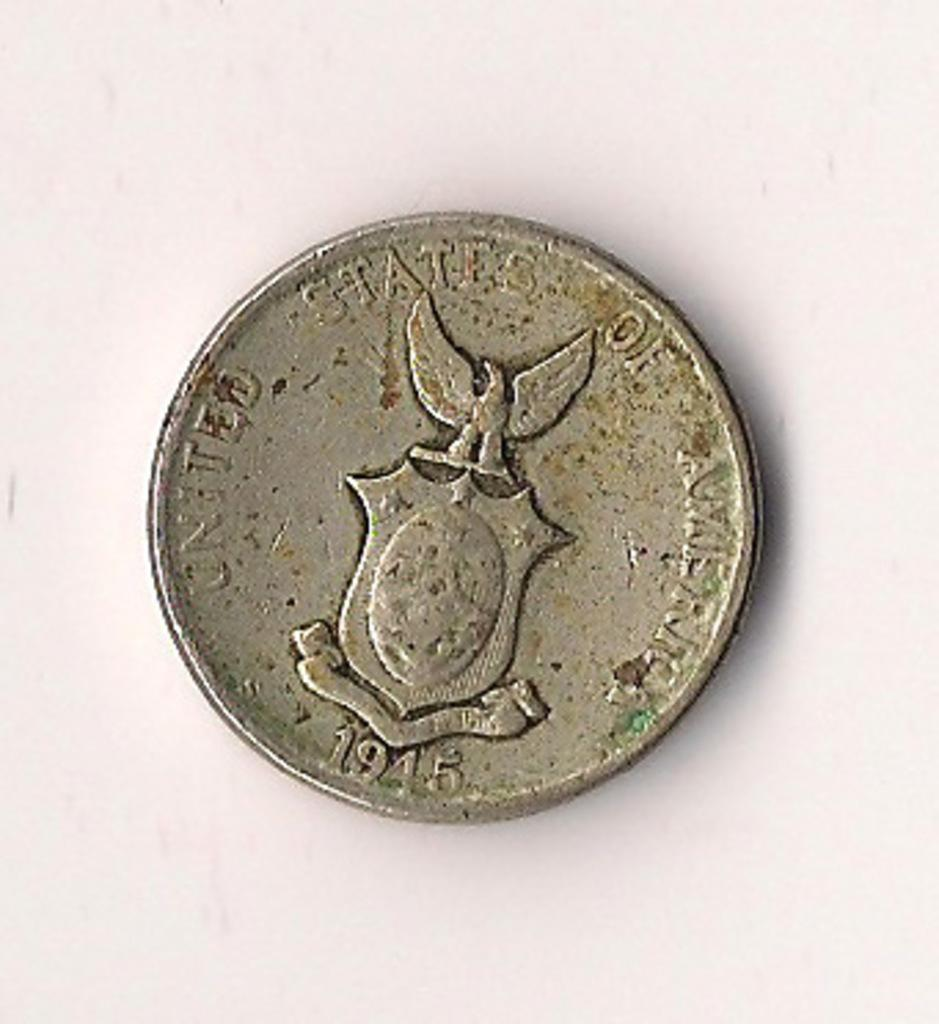<image>
Describe the image concisely. Silver coin showing an eagle holding a badge from year 1945. 